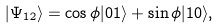Convert formula to latex. <formula><loc_0><loc_0><loc_500><loc_500>| \Psi _ { 1 2 } \rangle = \cos \phi | 0 1 \rangle + \sin \phi | 1 0 \rangle ,</formula> 